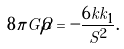Convert formula to latex. <formula><loc_0><loc_0><loc_500><loc_500>8 \pi G \dot { \rho } = - \frac { 6 k k _ { 1 } } { S ^ { 2 } } .</formula> 